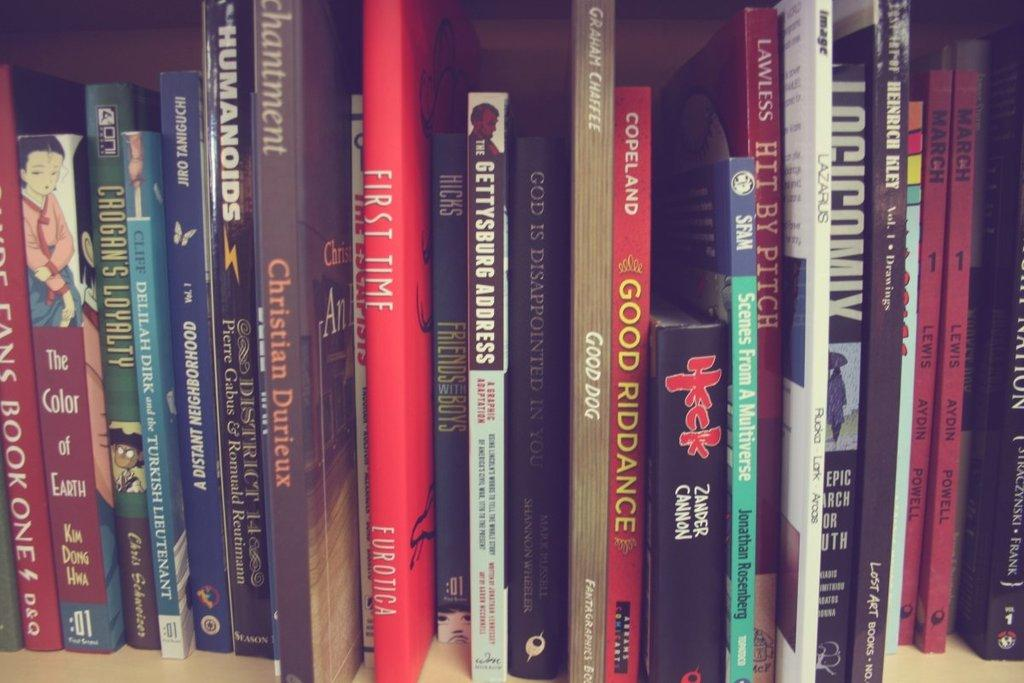<image>
Summarize the visual content of the image. A collection of books on a shelf has titles like HUMANOIDS, First Time, and Good Riddance. 